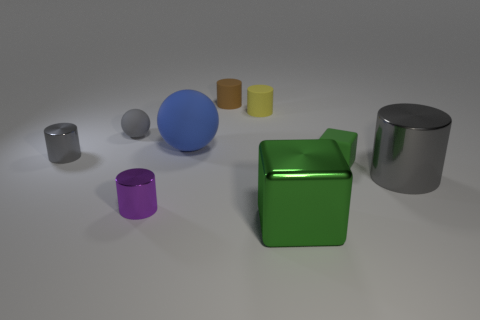Subtract all small brown cylinders. How many cylinders are left? 4 Subtract 1 spheres. How many spheres are left? 1 Subtract all purple cylinders. Subtract all blue cubes. How many cylinders are left? 4 Subtract all brown cylinders. How many cylinders are left? 4 Subtract all green blocks. How many blue balls are left? 1 Subtract all small blue things. Subtract all small green objects. How many objects are left? 8 Add 5 brown cylinders. How many brown cylinders are left? 6 Add 8 balls. How many balls exist? 10 Add 1 metal objects. How many objects exist? 10 Subtract 0 cyan spheres. How many objects are left? 9 